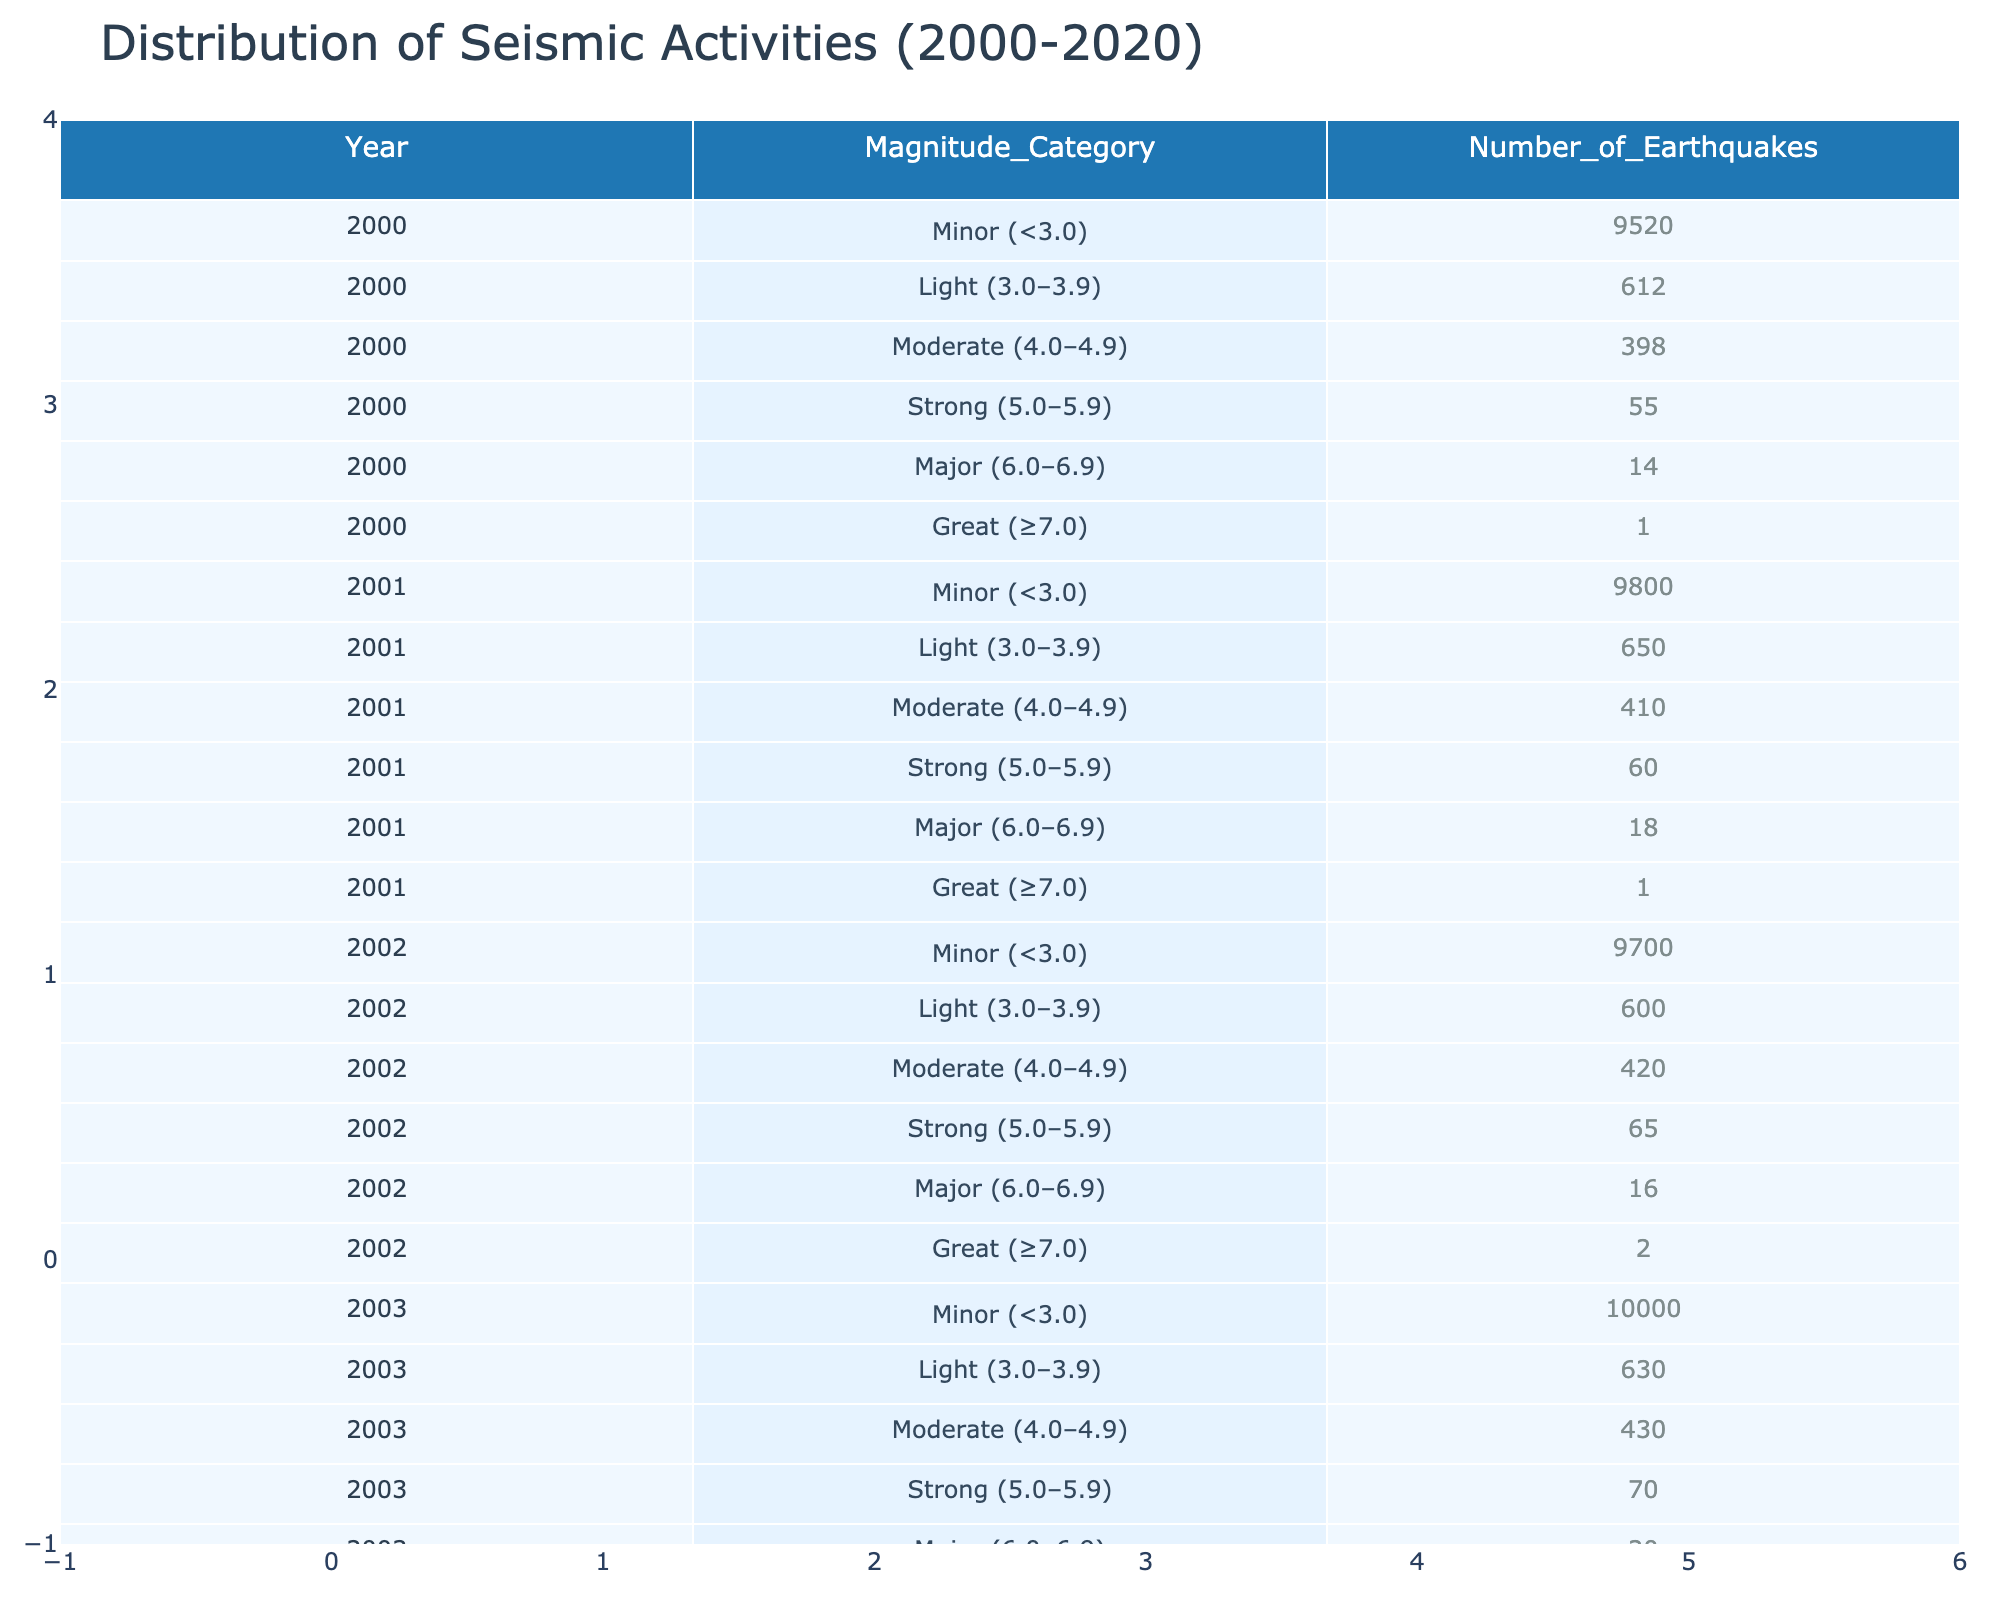What was the total number of minor earthquakes reported in 2005? In 2005, the table shows that there were 9,500 minor earthquakes.
Answer: 9,500 Which year had the highest number of moderate earthquakes? By scanning the table, the maximum number of moderate earthquakes occurs in 2004, with 450 earthquakes reported.
Answer: 450 What is the average number of strong earthquakes from 2000 to 2020? To find the average, sum the number of strong earthquakes for each year (55 + 60 + 70 + 75 + 58 + 63 + 68 + 70 + 62 + 66 + 72 + 65 + 67 + 70 + 68 + 62 + 65 + 73 + 68 + 70) which is 1378, and divide by the total years (21), giving an average of 65.09, rounding to 65.
Answer: 65 Were there any years between 2000 and 2020 with no great earthquakes? Yes, based on the table, there was no year without at least one great earthquake; every year shows at least one great earthquake.
Answer: No In which year did the highest number of light earthquakes occur? Examining the table, the highest number of light earthquakes was recorded in 2001, with 650 earthquakes.
Answer: 650 What was the trend in the number of minor earthquakes from 2000 to 2020? The trend shows fluctuations, starting at 9,520 in 2000, peaking at 10,000 in 2003, and decreasing to 9,700 by 2020, indicating an overall slight decrease toward the end of the period.
Answer: Slight decrease How many more moderate earthquakes were there in 2015 compared to 2017? In 2015, there were 450 moderate earthquakes, while in 2017 there were 425, so the difference is 450 - 425 = 25 additional moderate earthquakes in 2015.
Answer: 25 Was there an increase or decrease in the number of major earthquakes from 2007 to 2009? From 2007 to 2009, the number of major earthquakes decreased from 25 in 2007 to 19 in 2009, representing a decline of 6.
Answer: Decrease What is the total number of great earthquakes recorded from 2010 to 2015? Adding the number of great earthquakes in each year from 2010 to 2015 gives (5 + 5 + 2 + 4 + 3 + 1) = 20 total great earthquakes during that period.
Answer: 20 